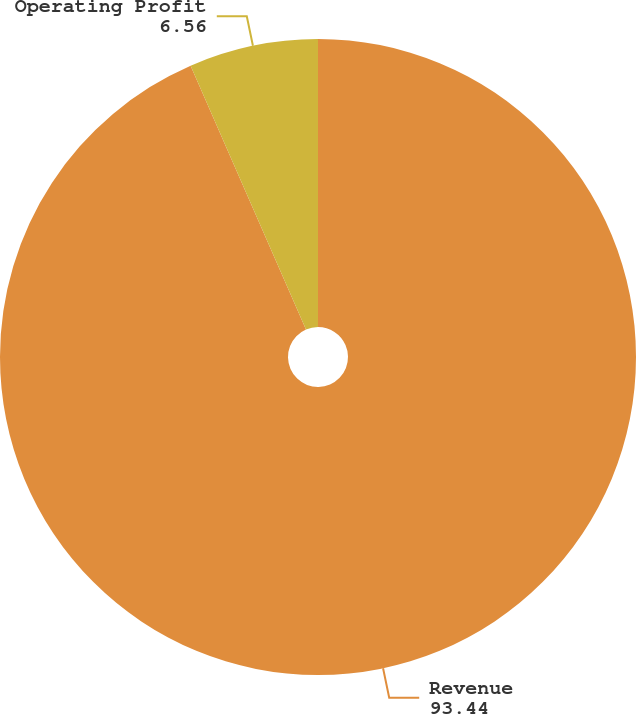Convert chart. <chart><loc_0><loc_0><loc_500><loc_500><pie_chart><fcel>Revenue<fcel>Operating Profit<nl><fcel>93.44%<fcel>6.56%<nl></chart> 